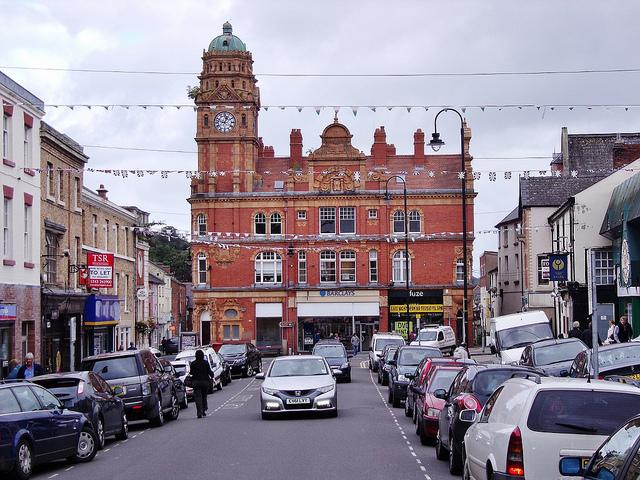Is this a colored picture?
Answer briefly. Yes. What car in on the road?
Answer briefly. Silver. Are there any people walking on the road?
Quick response, please. Yes. Toward which way is the traffic moving?
Write a very short answer. Forward. What time does the clock say?
Quick response, please. 10:05. Is this a two way street?
Give a very brief answer. No. 